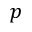Convert formula to latex. <formula><loc_0><loc_0><loc_500><loc_500>p</formula> 